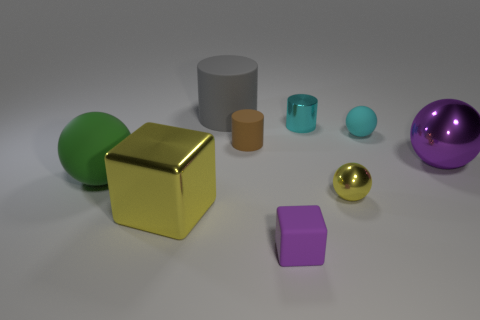Are there any other things that are made of the same material as the cyan cylinder?
Make the answer very short. Yes. Does the tiny thing on the left side of the tiny purple cube have the same color as the small matte object that is on the right side of the tiny cube?
Keep it short and to the point. No. What number of objects are behind the green rubber object and on the right side of the large gray rubber thing?
Your response must be concise. 4. What number of other objects are there of the same shape as the gray object?
Your response must be concise. 2. Is the number of green matte spheres right of the large purple metal thing greater than the number of red metal things?
Ensure brevity in your answer.  No. What color is the large ball that is on the right side of the big yellow thing?
Your answer should be compact. Purple. The thing that is the same color as the shiny cylinder is what size?
Provide a succinct answer. Small. What number of metal things are either big yellow cubes or tiny brown cylinders?
Your answer should be compact. 1. Is there a small purple rubber cube behind the small metal object that is behind the object that is to the left of the big block?
Your response must be concise. No. There is a small cyan rubber ball; how many purple metallic objects are left of it?
Keep it short and to the point. 0. 